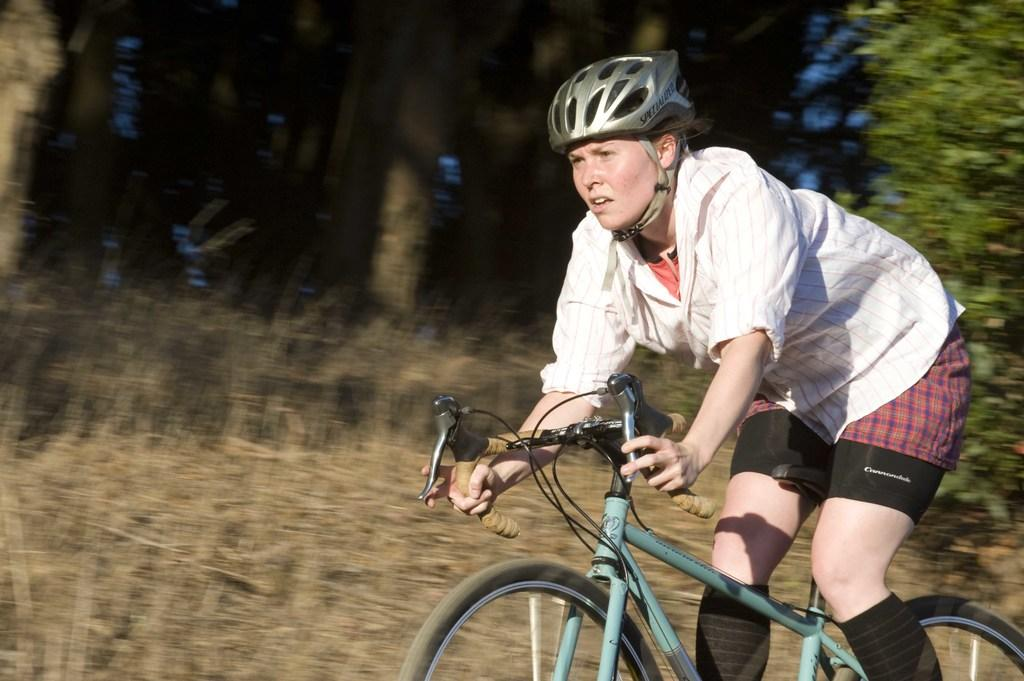Who is the main subject in the foreground of the picture? There is a woman in the foreground of the picture. What is the woman doing in the image? The woman is riding a bicycle. Can you describe the background of the image? The background of the image is blurred, and there are shrubs and trees visible. What is the weather like in the image? It is a sunny day. How many planes can be seen flying in the sky in the image? There are no planes visible in the image; it only features a woman riding a bicycle and a blurred background with shrubs and trees. 